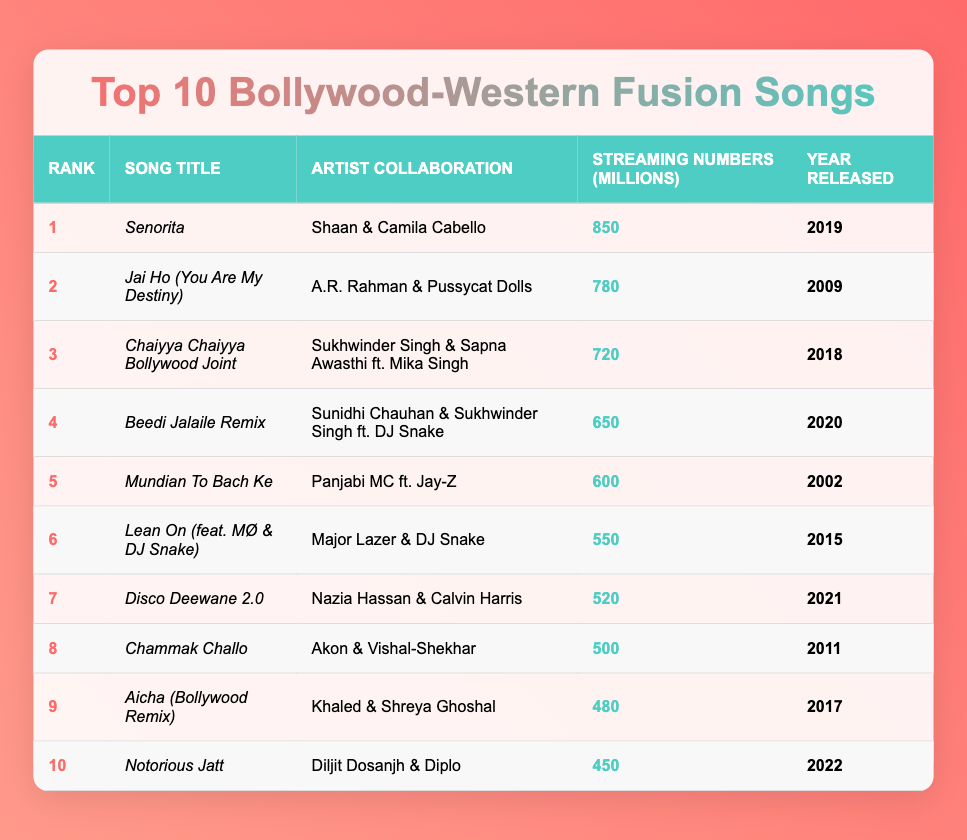What is the song with the highest streaming numbers? The highest streaming number in the table is 850 million, which belongs to the song "Senorita".
Answer: Senorita Which artist collaborated with Shaan on the song "Senorita"? Looking at the table, the artist who collaborated with Shaan on "Senorita" is Camila Cabello.
Answer: Camila Cabello What are the streaming numbers for "Lean On (feat. MØ & DJ Snake)"? The table shows that "Lean On (feat. MØ & DJ Snake)" has streaming numbers of 550 million.
Answer: 550 What is the average streaming number of the top three songs? To find the average, sum the streaming numbers of the top three songs: 850 + 780 + 720 = 2350. There are three songs, so the average is 2350 / 3 = 783.33.
Answer: 783.33 Is there a song released in 2020 in the top 10? Referring to the table, there is indeed a song released in 2020: "Beedi Jalaile Remix".
Answer: Yes Which song had more streaming numbers: "Chammak Challo" or "Aicha (Bollywood Remix)"? "Chammak Challo" has streaming numbers of 500 million, while "Aicha (Bollywood Remix)" has 480 million. Therefore, "Chammak Challo" has more streaming numbers.
Answer: Chammak Challo How many songs from the year 2010 or later are in the top 10? Looking at the table, the songs released from 2010 or later are "Senorita" (2019), "Chaiyya Chaiyya Bollywood Joint" (2018), "Beedi Jalaile Remix" (2020), "Lean On" (2015), "Disco Deewane 2.0" (2021), "Chammak Challo" (2011), "Aicha (Bollywood Remix)" (2017), and "Notorious Jatt" (2022). This gives us a total of 8 songs.
Answer: 8 Which artist has the most songs in the top 10? The artist with the most entries in the top 10 is DJ Snake, who has collaborated in two songs: "Beedi Jalaile Remix" and "Lean On".
Answer: DJ Snake What is the difference in streaming numbers between the song ranked first and the one ranked second? The streaming numbers for the first song "Senorita" is 850 million, and for the second song "Jai Ho" it's 780 million. The difference is 850 - 780 = 70 million.
Answer: 70 